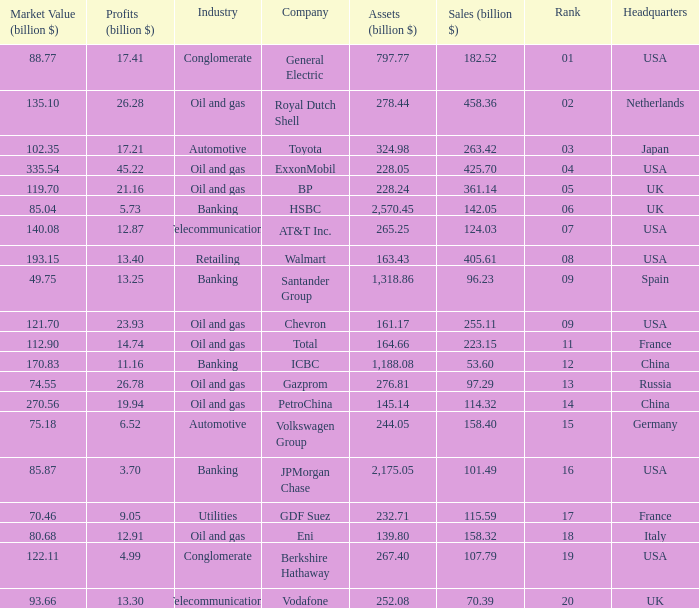What is the amount of exxonmobil's sales in billion dollars? 425.7. 